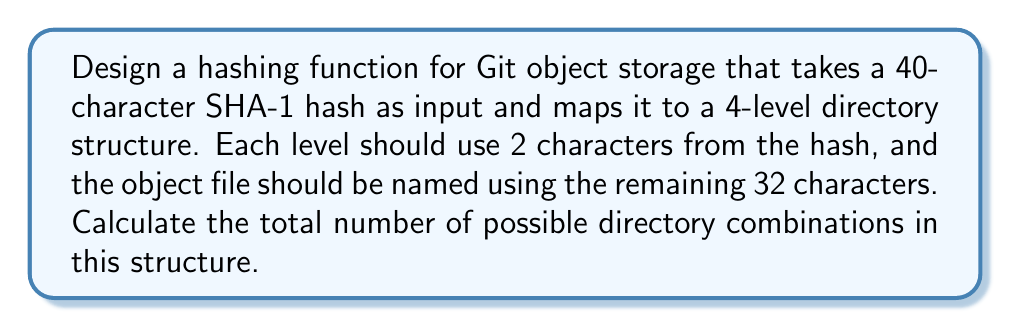Teach me how to tackle this problem. Let's approach this step-by-step:

1) The input is a 40-character SHA-1 hash. We'll use 8 characters (2 for each of the 4 levels) for the directory structure, leaving 32 for the filename.

2) For each directory level, we're using 2 characters from the hash. Each character in a SHA-1 hash can be one of 16 possible hexadecimal digits (0-9 and a-f).

3) The number of possible combinations for each 2-character directory name is:

   $16 \times 16 = 256$

4) We have 4 levels of directories, each with 256 possibilities. To find the total number of possible directory combinations, we multiply these together:

   $256 \times 256 \times 256 \times 256 = 256^4$

5) We can simplify this further:

   $256^4 = (2^8)^4 = 2^{32}$

6) To calculate this:

   $2^{32} = 4,294,967,296$

Therefore, the total number of possible directory combinations in this 4-level structure is 4,294,967,296.

This structure allows for efficient distribution of objects across directories, reducing the number of files in any single directory and improving file system performance.
Answer: $4,294,967,296$ 